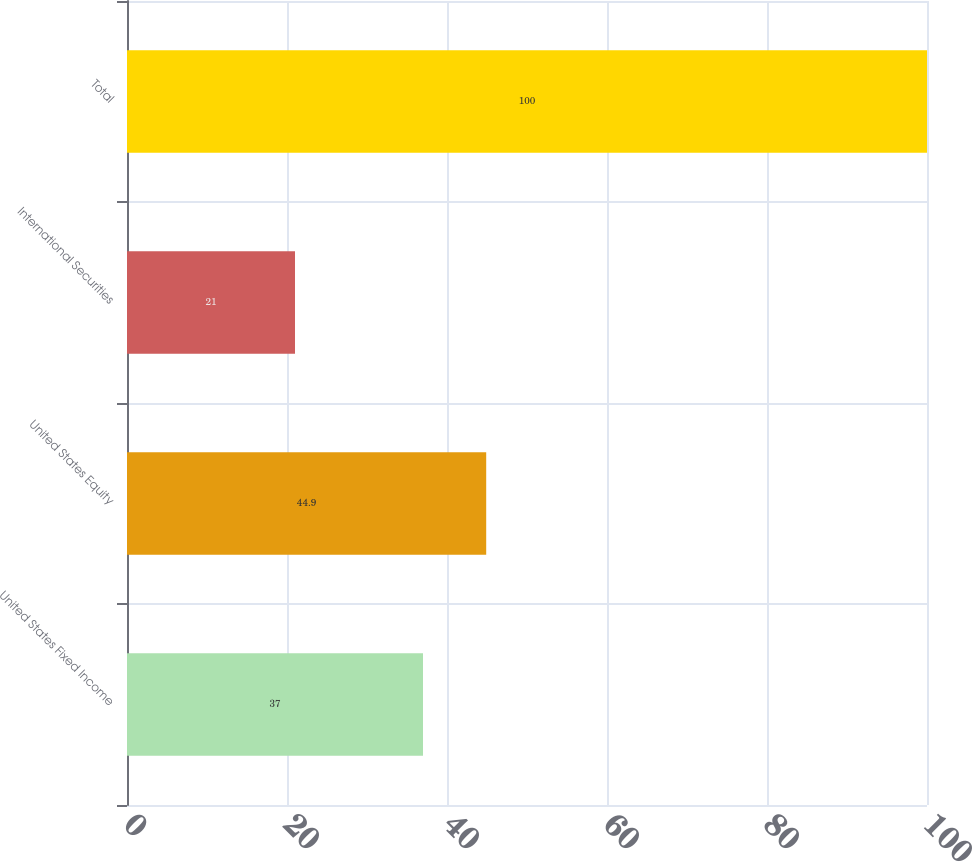Convert chart. <chart><loc_0><loc_0><loc_500><loc_500><bar_chart><fcel>United States Fixed Income<fcel>United States Equity<fcel>International Securities<fcel>Total<nl><fcel>37<fcel>44.9<fcel>21<fcel>100<nl></chart> 